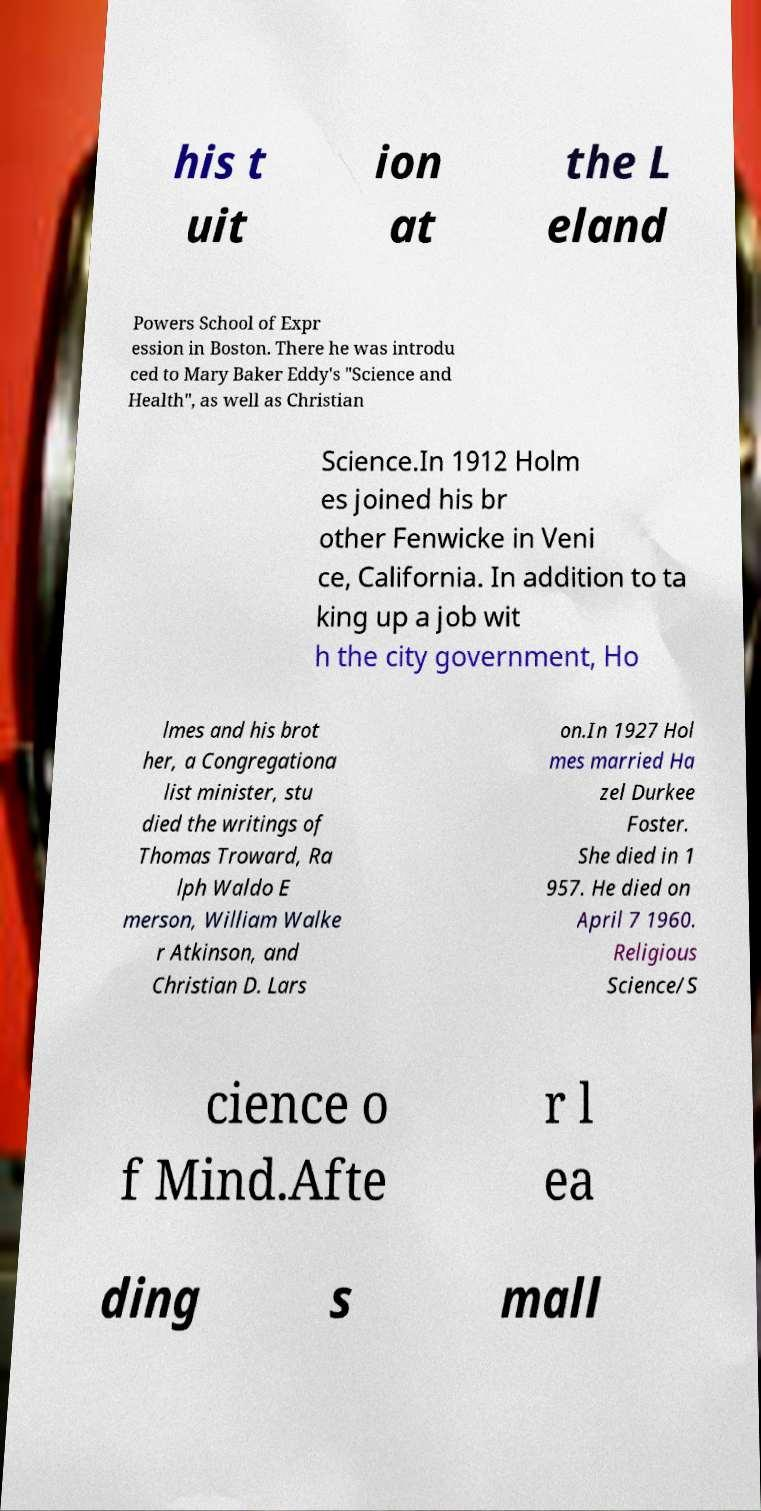There's text embedded in this image that I need extracted. Can you transcribe it verbatim? his t uit ion at the L eland Powers School of Expr ession in Boston. There he was introdu ced to Mary Baker Eddy's "Science and Health", as well as Christian Science.In 1912 Holm es joined his br other Fenwicke in Veni ce, California. In addition to ta king up a job wit h the city government, Ho lmes and his brot her, a Congregationa list minister, stu died the writings of Thomas Troward, Ra lph Waldo E merson, William Walke r Atkinson, and Christian D. Lars on.In 1927 Hol mes married Ha zel Durkee Foster. She died in 1 957. He died on April 7 1960. Religious Science/S cience o f Mind.Afte r l ea ding s mall 